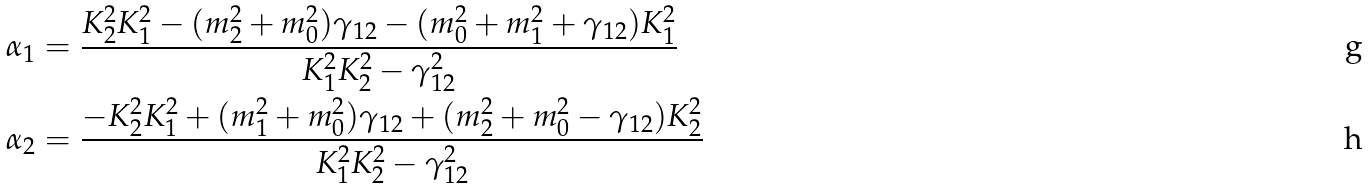<formula> <loc_0><loc_0><loc_500><loc_500>\alpha _ { 1 } & = \frac { K ^ { 2 } _ { 2 } K ^ { 2 } _ { 1 } - ( m ^ { 2 } _ { 2 } + m ^ { 2 } _ { 0 } ) \gamma _ { 1 2 } - ( m ^ { 2 } _ { 0 } + m ^ { 2 } _ { 1 } + \gamma _ { 1 2 } ) K ^ { 2 } _ { 1 } } { K ^ { 2 } _ { 1 } K ^ { 2 } _ { 2 } - \gamma _ { 1 2 } ^ { 2 } } \\ \alpha _ { 2 } & = \frac { - K ^ { 2 } _ { 2 } K ^ { 2 } _ { 1 } + ( m ^ { 2 } _ { 1 } + m ^ { 2 } _ { 0 } ) \gamma _ { 1 2 } + ( m ^ { 2 } _ { 2 } + m ^ { 2 } _ { 0 } - \gamma _ { 1 2 } ) K ^ { 2 } _ { 2 } } { K ^ { 2 } _ { 1 } K ^ { 2 } _ { 2 } - \gamma _ { 1 2 } ^ { 2 } }</formula> 